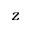<formula> <loc_0><loc_0><loc_500><loc_500>z</formula> 